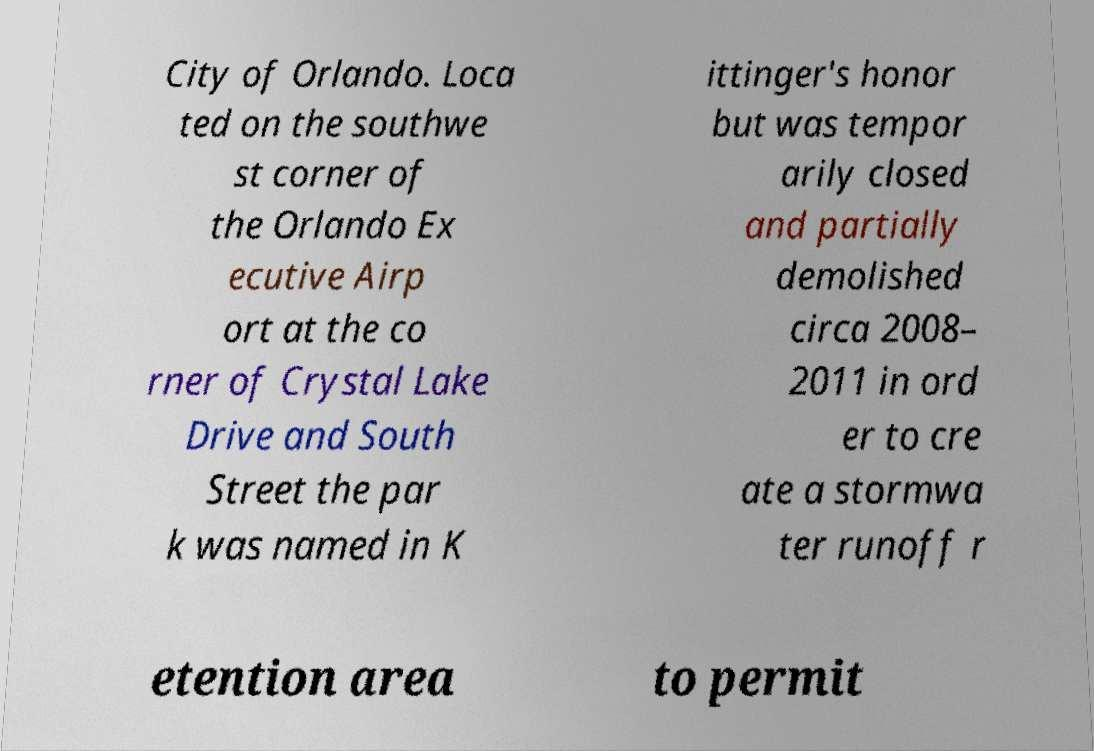There's text embedded in this image that I need extracted. Can you transcribe it verbatim? City of Orlando. Loca ted on the southwe st corner of the Orlando Ex ecutive Airp ort at the co rner of Crystal Lake Drive and South Street the par k was named in K ittinger's honor but was tempor arily closed and partially demolished circa 2008– 2011 in ord er to cre ate a stormwa ter runoff r etention area to permit 